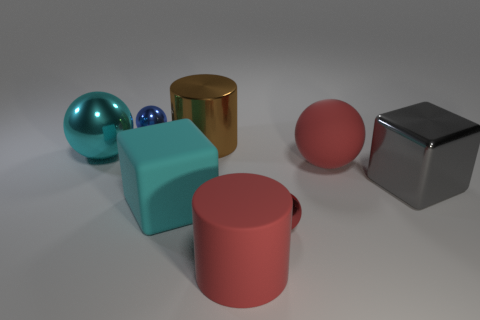Subtract all blue cylinders. How many red spheres are left? 2 Add 1 small blue shiny spheres. How many objects exist? 9 Subtract all red matte balls. How many balls are left? 3 Subtract all blue balls. How many balls are left? 3 Add 3 red shiny spheres. How many red shiny spheres exist? 4 Subtract 1 gray blocks. How many objects are left? 7 Subtract all blocks. How many objects are left? 6 Subtract all cyan balls. Subtract all brown blocks. How many balls are left? 3 Subtract all big brown metallic objects. Subtract all large things. How many objects are left? 1 Add 3 red metallic objects. How many red metallic objects are left? 4 